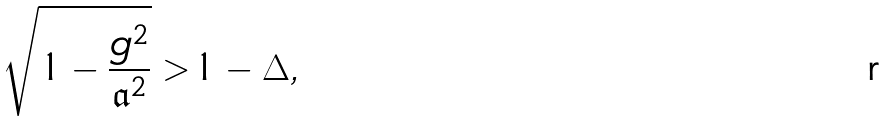Convert formula to latex. <formula><loc_0><loc_0><loc_500><loc_500>\sqrt { 1 - \frac { g ^ { 2 } } { \mathfrak { a } ^ { 2 } } } > 1 - \Delta ,</formula> 